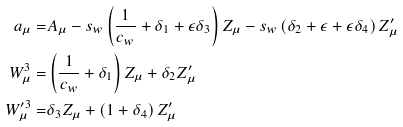Convert formula to latex. <formula><loc_0><loc_0><loc_500><loc_500>a _ { \mu } = & A _ { \mu } - s _ { w } \left ( \frac { 1 } { c _ { w } } + \delta _ { 1 } + \epsilon \delta _ { 3 } \right ) Z _ { \mu } - s _ { w } \left ( \delta _ { 2 } + \epsilon + \epsilon \delta _ { 4 } \right ) Z ^ { \prime } _ { \mu } \\ W ^ { 3 } _ { \mu } = & \left ( \frac { 1 } { c _ { w } } + \delta _ { 1 } \right ) Z _ { \mu } + \delta _ { 2 } Z _ { \mu } ^ { \prime } \\ W ^ { \prime 3 } _ { \mu } = & \delta _ { 3 } Z _ { \mu } + \left ( 1 + \delta _ { 4 } \right ) Z _ { \mu } ^ { \prime }</formula> 